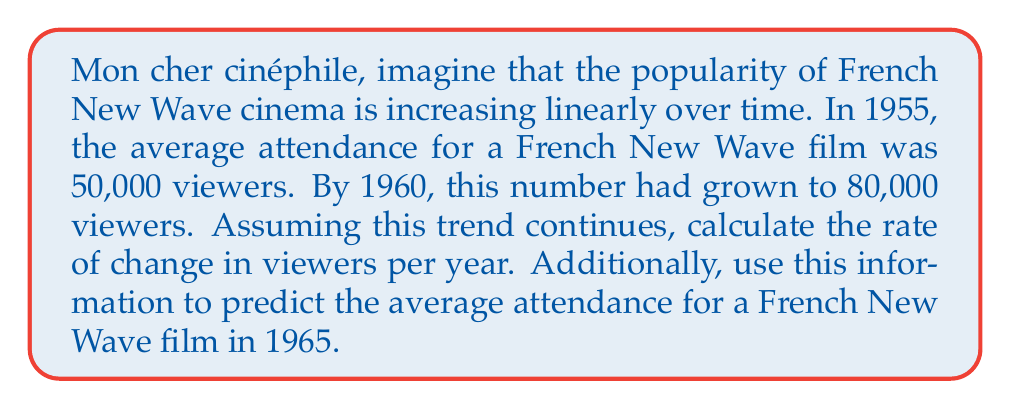Solve this math problem. Let's approach this problem step by step, using the linear equation model:

1) First, we need to identify our variables:
   Let $x$ represent the number of years since 1955
   Let $y$ represent the number of viewers

2) We can create two points from the given information:
   (0, 50000) for 1955
   (5, 80000) for 1960

3) To find the rate of change (slope), we use the formula:

   $$m = \frac{y_2 - y_1}{x_2 - x_1} = \frac{80000 - 50000}{5 - 0} = \frac{30000}{5} = 6000$$

   This means the number of viewers is increasing by 6000 per year.

4) Now we can form our linear equation:
   $$y = mx + b$$
   Where $m = 6000$ and $b = 50000$ (the y-intercept, which is the number of viewers in 1955)

   So our equation is:
   $$y = 6000x + 50000$$

5) To predict the attendance in 1965, we calculate for $x = 10$ (10 years after 1955):
   $$y = 6000(10) + 50000 = 60000 + 50000 = 110000$$

Therefore, the predicted attendance in 1965 would be 110,000 viewers.
Answer: The rate of change is 6000 viewers per year. The predicted attendance for a French New Wave film in 1965 is 110,000 viewers. 